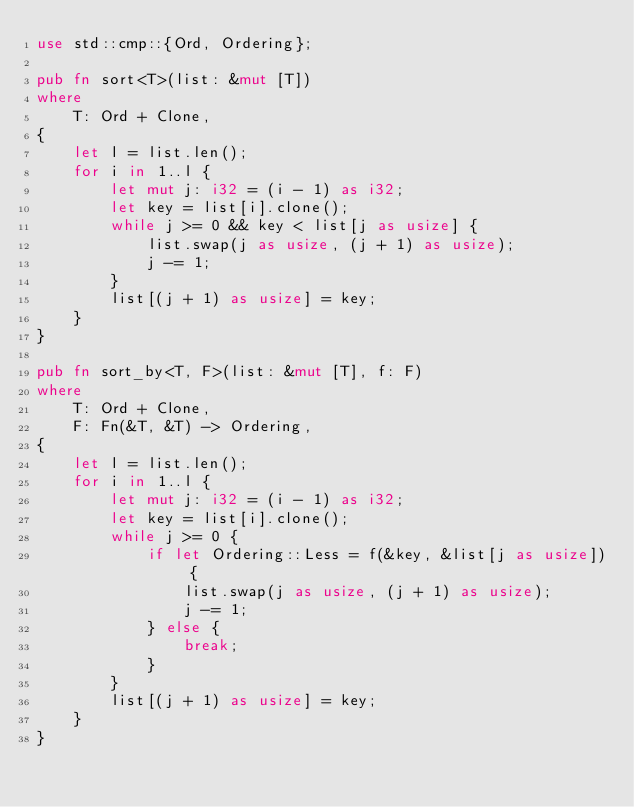<code> <loc_0><loc_0><loc_500><loc_500><_Rust_>use std::cmp::{Ord, Ordering};

pub fn sort<T>(list: &mut [T])
where
    T: Ord + Clone,
{
    let l = list.len();
    for i in 1..l {
        let mut j: i32 = (i - 1) as i32;
        let key = list[i].clone();
        while j >= 0 && key < list[j as usize] {
            list.swap(j as usize, (j + 1) as usize);
            j -= 1;
        }
        list[(j + 1) as usize] = key;
    }
}

pub fn sort_by<T, F>(list: &mut [T], f: F)
where
    T: Ord + Clone,
    F: Fn(&T, &T) -> Ordering,
{
    let l = list.len();
    for i in 1..l {
        let mut j: i32 = (i - 1) as i32;
        let key = list[i].clone();
        while j >= 0 {
            if let Ordering::Less = f(&key, &list[j as usize]) {
                list.swap(j as usize, (j + 1) as usize);
                j -= 1;
            } else {
                break;
            }
        }
        list[(j + 1) as usize] = key;
    }
}
</code> 